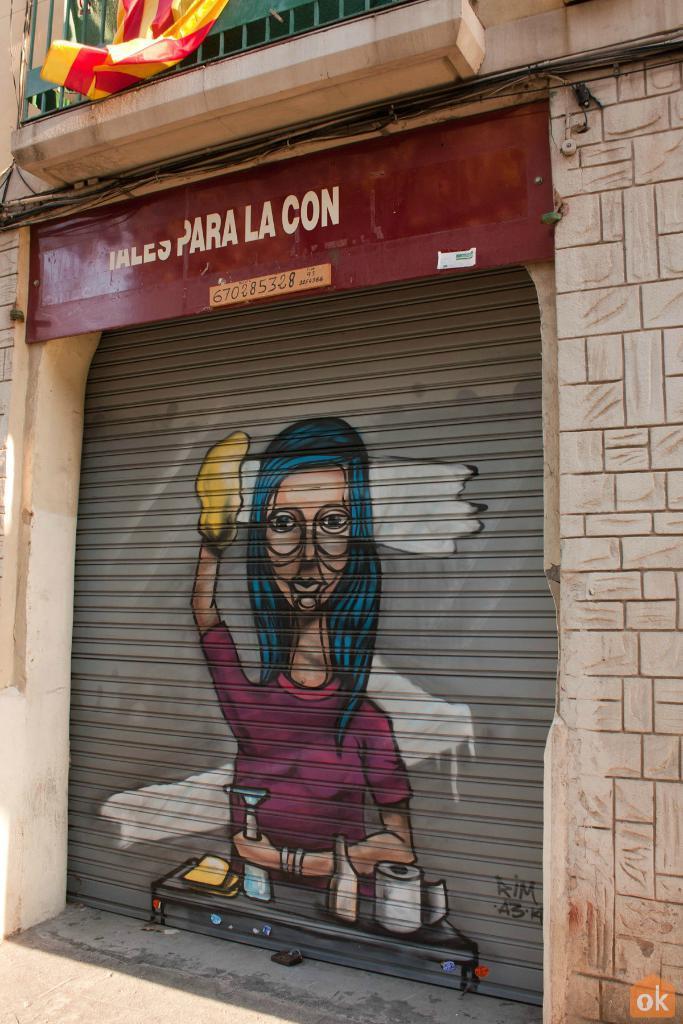How would you summarize this image in a sentence or two? In this image there is a wall having a shutter. On the shutter there is an image painted. A person is holding a bottle which is on the table having a paper roll and few objects. Top of the image there is a balcony having clothes. 